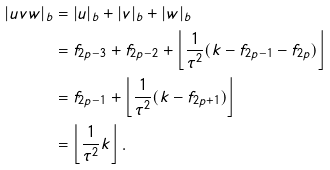Convert formula to latex. <formula><loc_0><loc_0><loc_500><loc_500>| u v w | _ { b } & = | u | _ { b } + | v | _ { b } + | w | _ { b } \\ & = f _ { 2 p - 3 } + f _ { 2 p - 2 } + \left \lfloor \frac { 1 } { \tau ^ { 2 } } ( k - f _ { 2 p - 1 } - f _ { 2 p } ) \right \rfloor \\ & = f _ { 2 p - 1 } + \left \lfloor \frac { 1 } { \tau ^ { 2 } } ( k - f _ { 2 p + 1 } ) \right \rfloor \\ & = \left \lfloor \frac { 1 } { \tau ^ { 2 } } k \right \rfloor .</formula> 